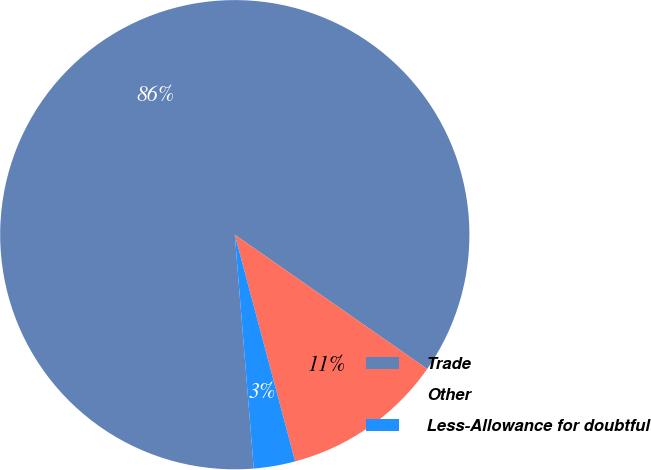<chart> <loc_0><loc_0><loc_500><loc_500><pie_chart><fcel>Trade<fcel>Other<fcel>Less-Allowance for doubtful<nl><fcel>85.98%<fcel>11.16%<fcel>2.85%<nl></chart> 